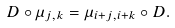<formula> <loc_0><loc_0><loc_500><loc_500>D \circ \mu _ { j , k } = \mu _ { i + j , i + k } \circ D .</formula> 